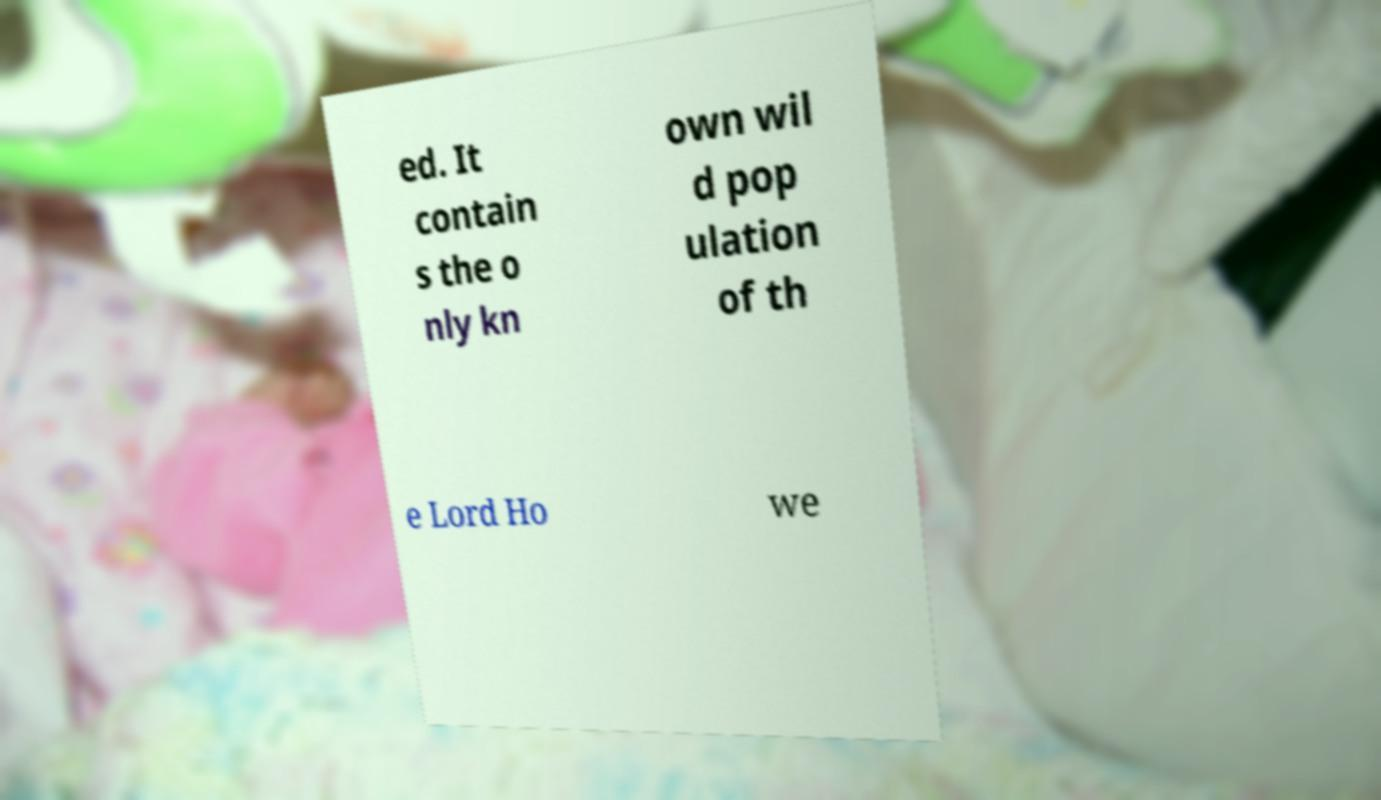Can you accurately transcribe the text from the provided image for me? ed. It contain s the o nly kn own wil d pop ulation of th e Lord Ho we 